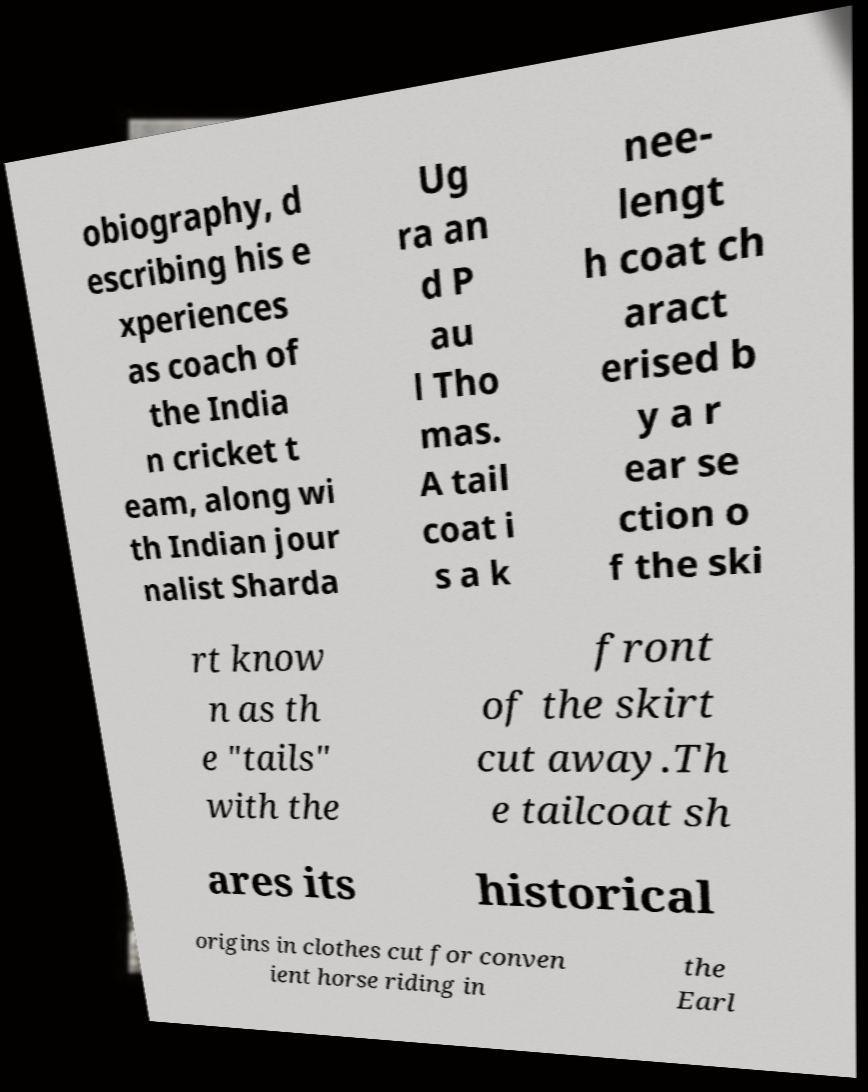Please read and relay the text visible in this image. What does it say? obiography, d escribing his e xperiences as coach of the India n cricket t eam, along wi th Indian jour nalist Sharda Ug ra an d P au l Tho mas. A tail coat i s a k nee- lengt h coat ch aract erised b y a r ear se ction o f the ski rt know n as th e "tails" with the front of the skirt cut away.Th e tailcoat sh ares its historical origins in clothes cut for conven ient horse riding in the Earl 